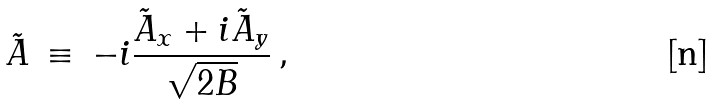<formula> <loc_0><loc_0><loc_500><loc_500>\tilde { A } \, \equiv \, - i \frac { \tilde { A } _ { x } + i \tilde { A } _ { y } } { \sqrt { 2 B } } \, ,</formula> 